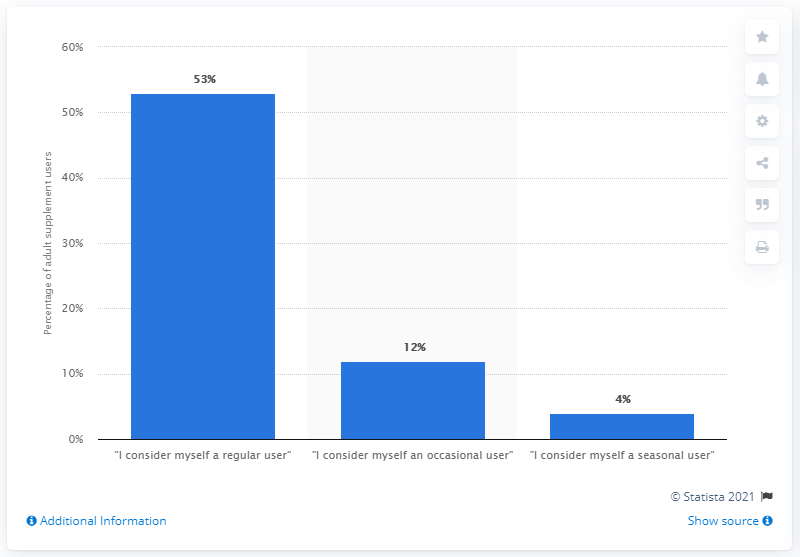Point out several critical features in this image. According to our survey, a significant percentage of people consider themselves to be seasonal users, with 4% of respondents answering in the affirmative. In 2013, among US adults, 65% self-identified as occasional or regular users of dietary or nutritional supplements. 